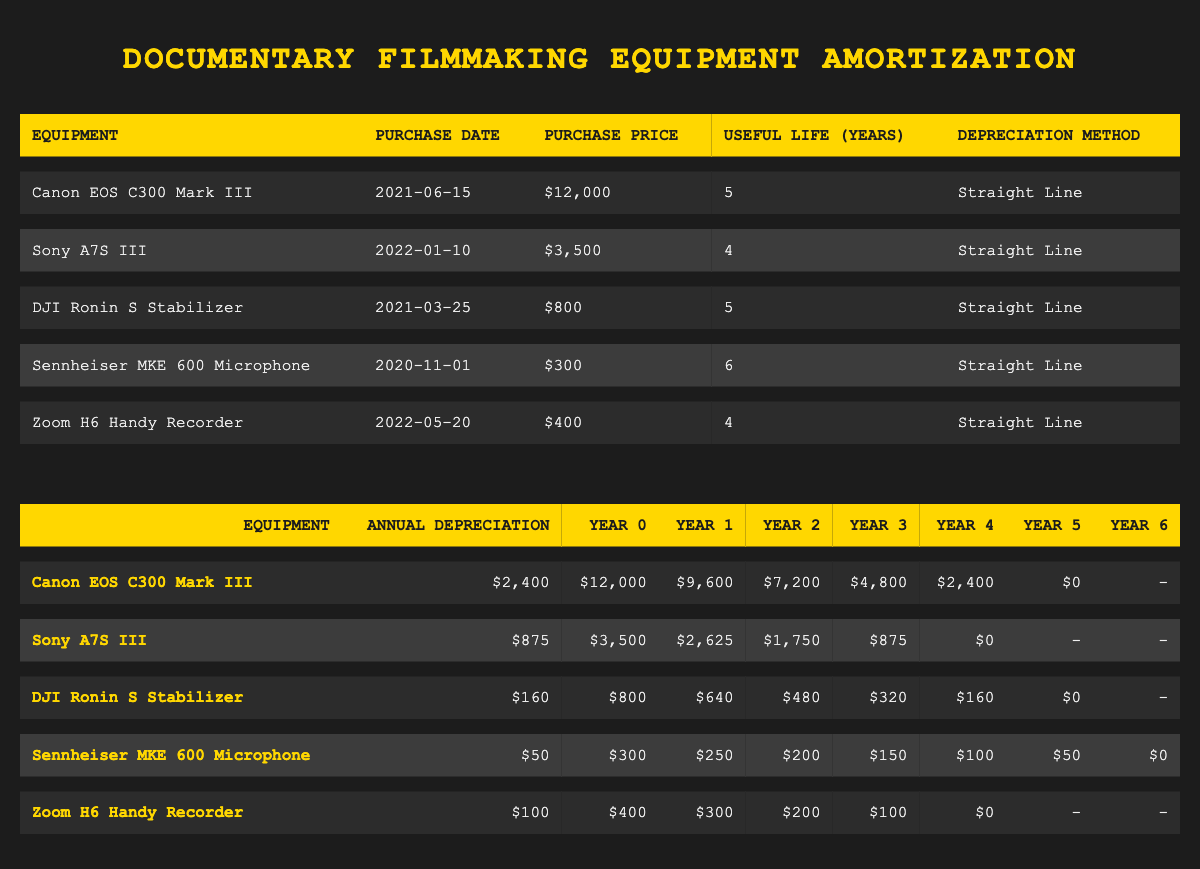What is the annual depreciation for the Canon EOS C300 Mark III? The table lists the annual depreciation for the Canon EOS C300 Mark III in the second column of the amortization table. It shows that the annual depreciation is $2,400.
Answer: 2400 How much was the purchase price of the Sony A7S III? The purchase price of the Sony A7S III is provided in the equipment table in the third column. It is noted as $3,500.
Answer: 3500 What is the total depreciation at the end of Year 5 for the DJI Ronin S Stabilizer? To find the total depreciation at the end of Year 5 for the DJI Ronin S Stabilizer, look at the total depreciation row in the amortization table. It indicates $800 at Year 5.
Answer: 800 Which item has the lowest annual depreciation? By comparing the annual depreciation figures in the amortization table, the Sennheiser MKE 600 Microphone has the lowest annual depreciation of $50, compared to the others listed.
Answer: 50 What is the average remaining book value of all equipment after Year 1? The remaining book values after Year 1 are $9,600 (Canon EOS C300 Mark III), $2,625 (Sony A7S III), $640 (DJI Ronin S Stabilizer), $250 (Sennheiser MKE 600 Microphone), and $300 (Zoom H6 Handy Recorder). Adding these values gives 9,600 + 2,625 + 640 + 250 + 300 = 13,415. Dividing by 5 gives 13,415 / 5 = 2,683.
Answer: 2683 Is it true that the Zoom H6 Handy Recorder has a purchase price exceeding $500? Referring to the equipment table, the purchase price of the Zoom H6 Handy Recorder is $400, which is not more than $500. Therefore, the statement is false.
Answer: False 